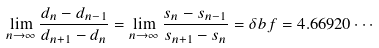Convert formula to latex. <formula><loc_0><loc_0><loc_500><loc_500>\lim _ { n \rightarrow \infty } \frac { d _ { n } - d _ { n - 1 } } { d _ { n + 1 } - d _ { n } } = \lim _ { n \rightarrow \infty } \frac { s _ { n } - s _ { n - 1 } } { s _ { n + 1 } - s _ { n } } = \delta b f = 4 . 6 6 9 2 0 \cdots</formula> 